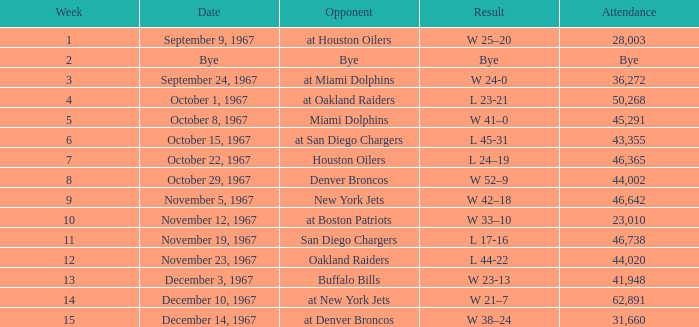Who was the rival post week 9 with an attendance of 44,020? Oakland Raiders. 